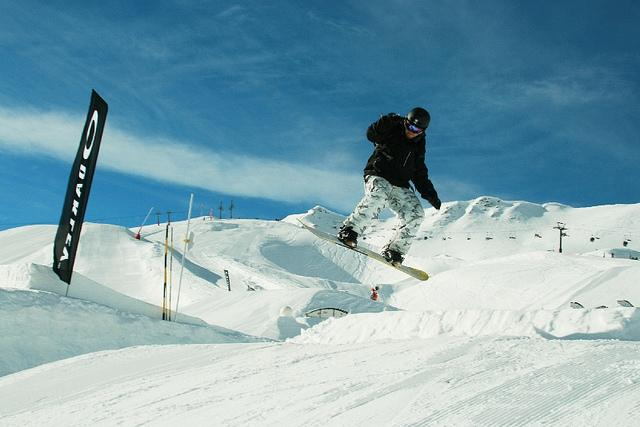Why is the black banner most likely flying in the snowboarder's location?

Choices:
A) shade
B) decoration
C) warning
D) advertisement advertisement 